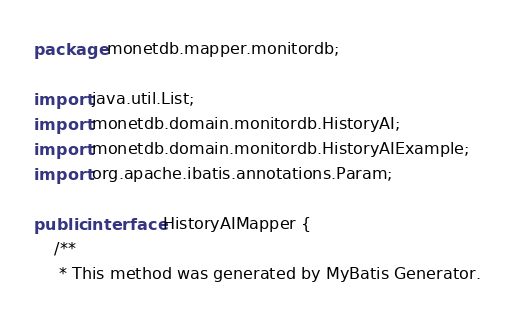Convert code to text. <code><loc_0><loc_0><loc_500><loc_500><_Java_>package monetdb.mapper.monitordb;

import java.util.List;
import monetdb.domain.monitordb.HistoryAI;
import monetdb.domain.monitordb.HistoryAIExample;
import org.apache.ibatis.annotations.Param;

public interface HistoryAIMapper {
    /**
     * This method was generated by MyBatis Generator.</code> 